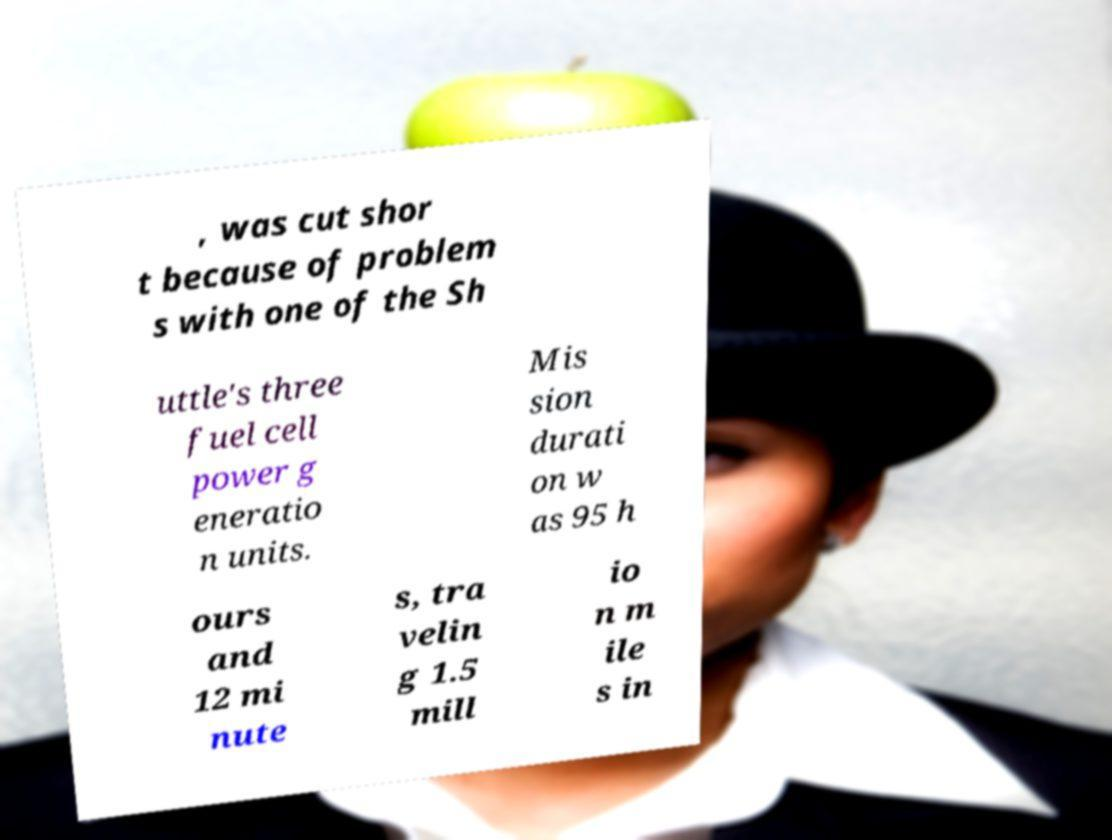Please identify and transcribe the text found in this image. , was cut shor t because of problem s with one of the Sh uttle's three fuel cell power g eneratio n units. Mis sion durati on w as 95 h ours and 12 mi nute s, tra velin g 1.5 mill io n m ile s in 